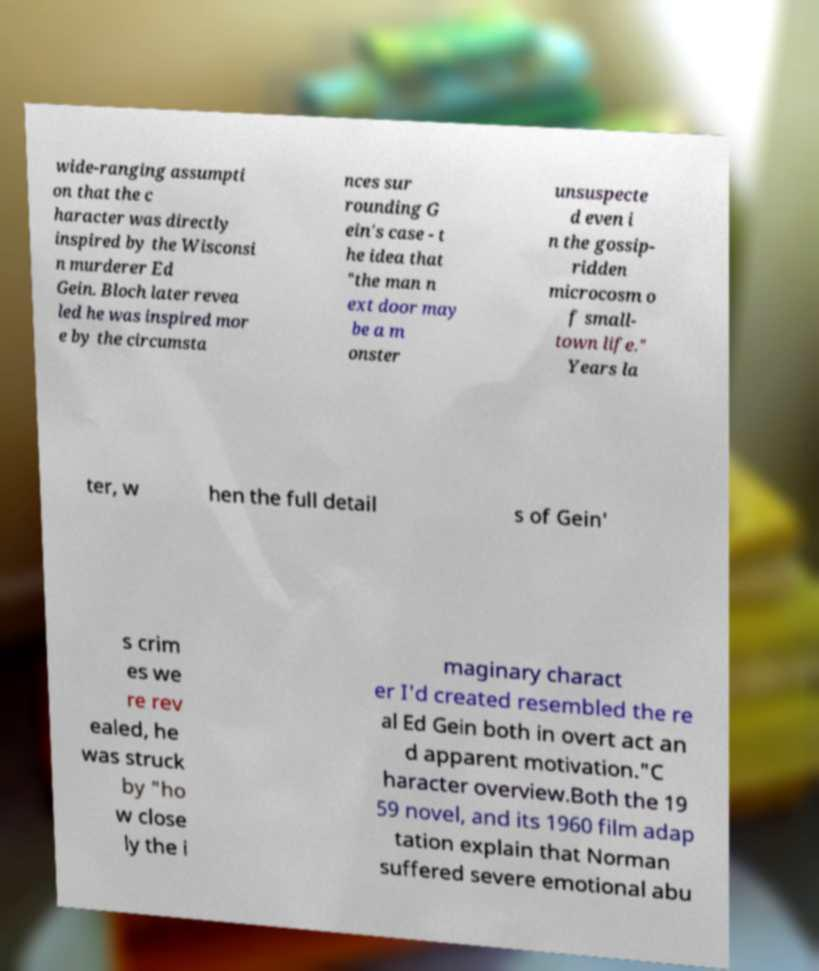What messages or text are displayed in this image? I need them in a readable, typed format. wide-ranging assumpti on that the c haracter was directly inspired by the Wisconsi n murderer Ed Gein. Bloch later revea led he was inspired mor e by the circumsta nces sur rounding G ein's case - t he idea that "the man n ext door may be a m onster unsuspecte d even i n the gossip- ridden microcosm o f small- town life." Years la ter, w hen the full detail s of Gein' s crim es we re rev ealed, he was struck by "ho w close ly the i maginary charact er I'd created resembled the re al Ed Gein both in overt act an d apparent motivation."C haracter overview.Both the 19 59 novel, and its 1960 film adap tation explain that Norman suffered severe emotional abu 